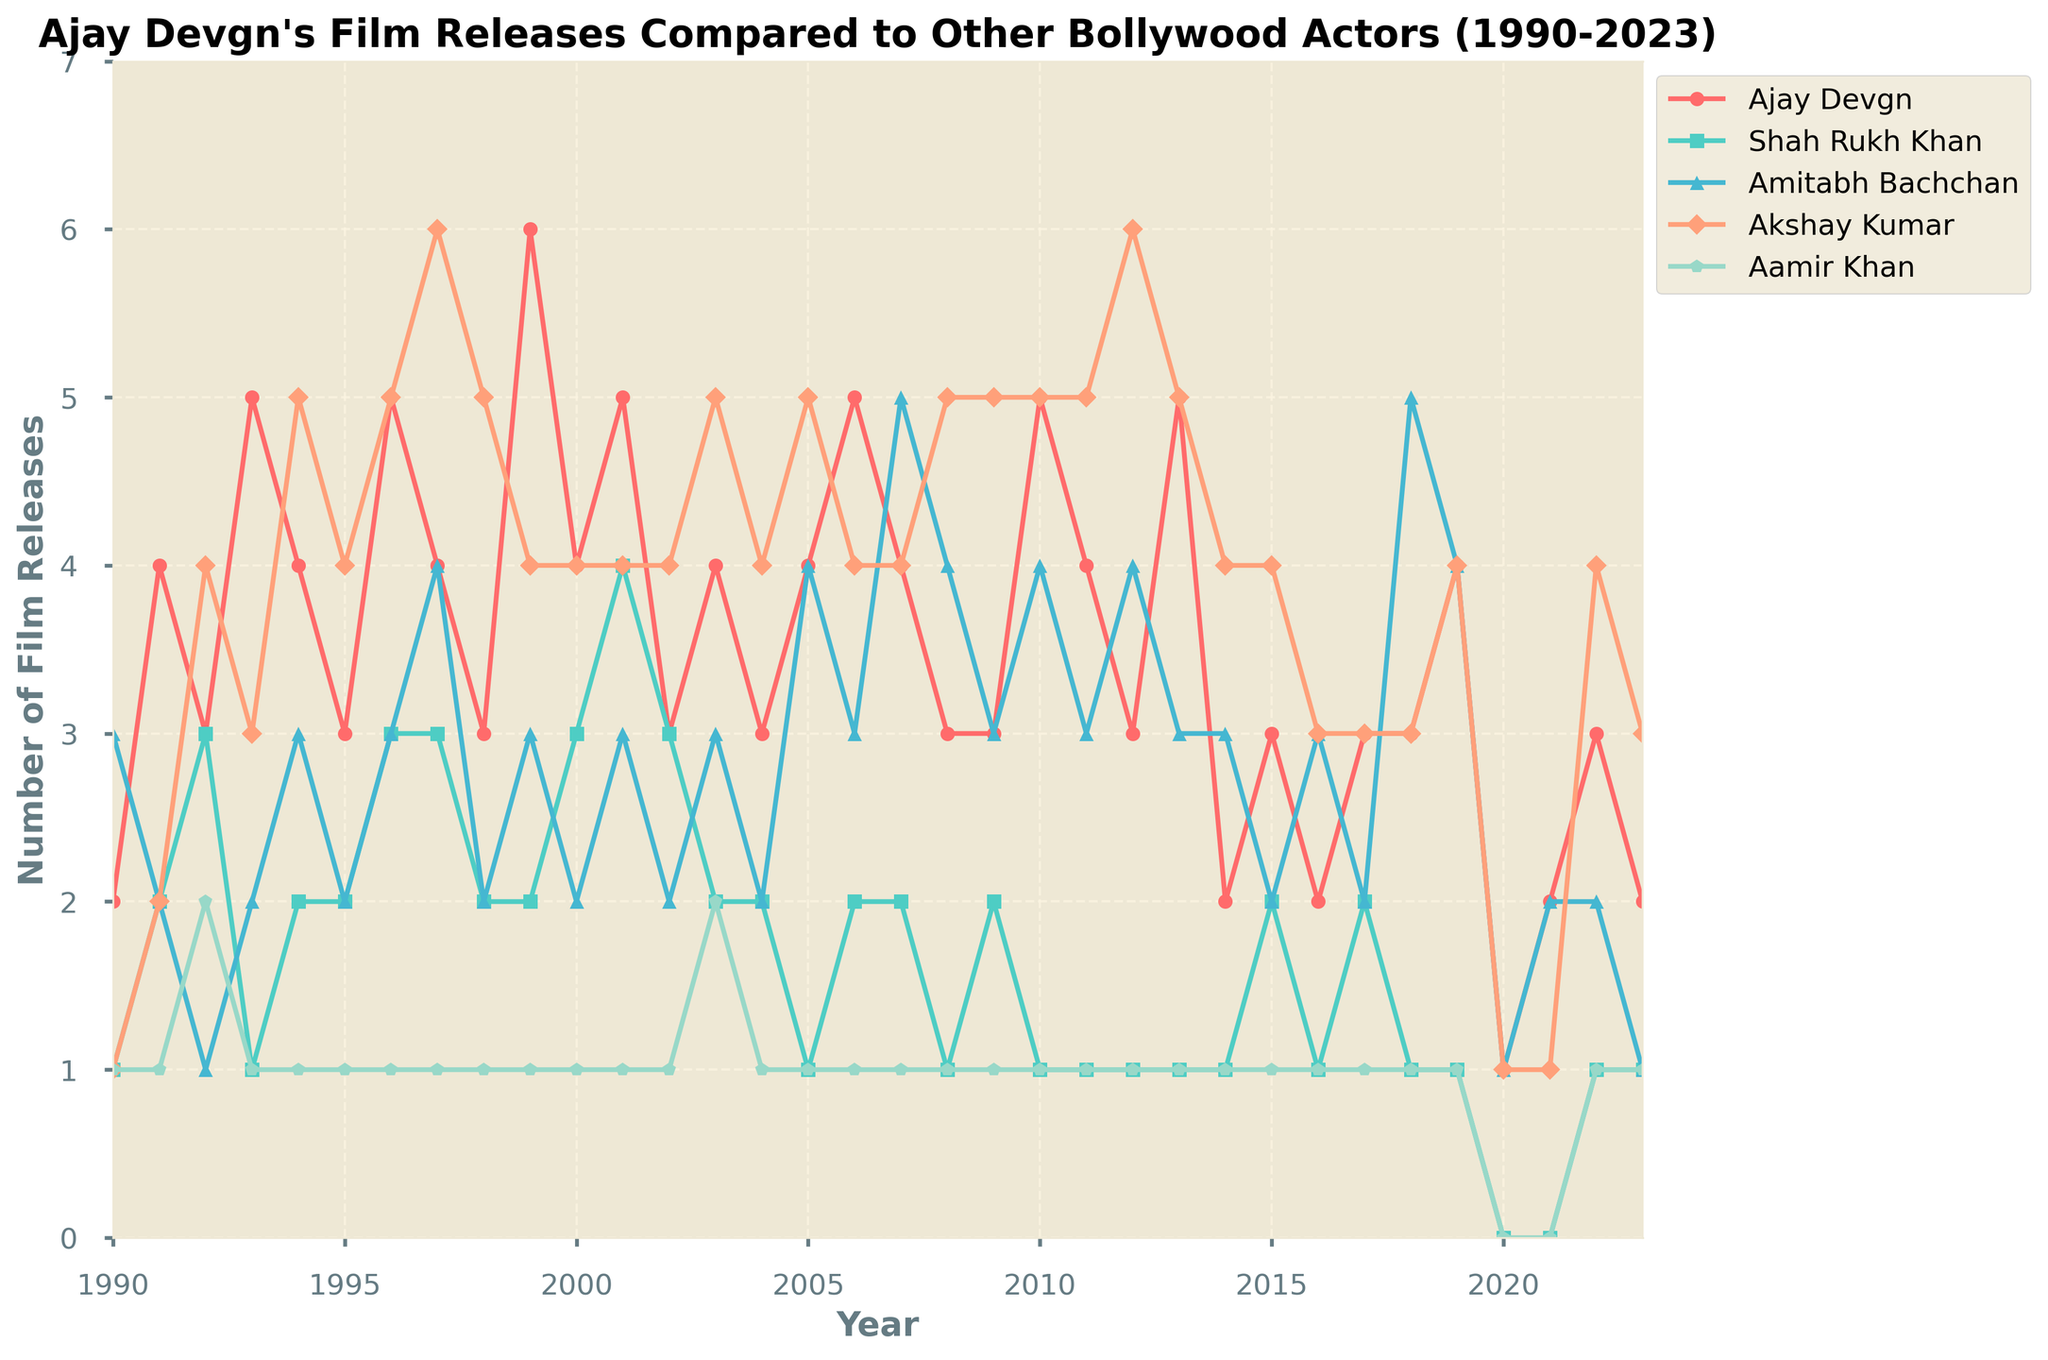What year did Ajay Devgn release the most films? The highest point in Ajay Devgn's line represents the year 1999 with 6 film releases.
Answer: 1999 Which actor had the most film releases in any single year and what was the year? By comparing the highest points of all the lines, Akshay Kumar released the most films, with 6 releases, both in 1997 and 2012.
Answer: Akshay Kumar, 1997 and 2012 In which year did Ajay Devgn release more films than Shah Rukh Khan but fewer than Akshay Kumar? In 1996, Ajay Devgn released 5 films, which is more than Shah Rukh Khan's 3 films but fewer than Akshay Kumar's 5 films.
Answer: 1996 What's the average number of films released per year by Ajay Devgn from 1990 to 2023? Summing up all the yearly film releases for Ajay Devgn over 34 years gives a total of 117. Average is 117 divided by 34.
Answer: 3.44 Compare the number of film releases by Ajay Devgn, Shah Rukh Khan, and Akshay Kumar in the year 2000 Ajay Devgn released 4 films, Shah Rukh Khan released 3 films, and Akshay Kumar released 4 films in the year 2000.
Answer: Ajay Devgn: 4, Shah Rukh Khan: 3, Akshay Kumar: 4 Did Amitabh Bachchan ever release more films than Ajay Devgn in any given year? By comparing the lines, Amitabh Bachchan never released more films in a year than Ajay Devgn in the years 1990 to 2023.
Answer: No How many years did both Ajay Devgn and Aamir Khan have the same number of film releases? By observing the overlap points of the lines, they had the same number of film releases in the years 1990, 1993, 1994, 1995, and 2003.
Answer: 5 What is the lowest number of films released in a year by Shah Rukh Khan? By locating the minimum point in Shah Rukh Khan's line, the years 2020 and 2021 show 0 releases.
Answer: 0 Which actor had the most consistent number of film releases per year? Comparing the fluctuations in the lines, Aamir Khan consistently released 1 film nearly every year from 1990 to 2023.
Answer: Aamir Khan In which year did Ajay Devgn release only one film and was this the fewest he ever released in a year? Ajay Devgn released only one film in the year 2020, and yes, it was his fewest releases in a year.
Answer: 2020, Yes 